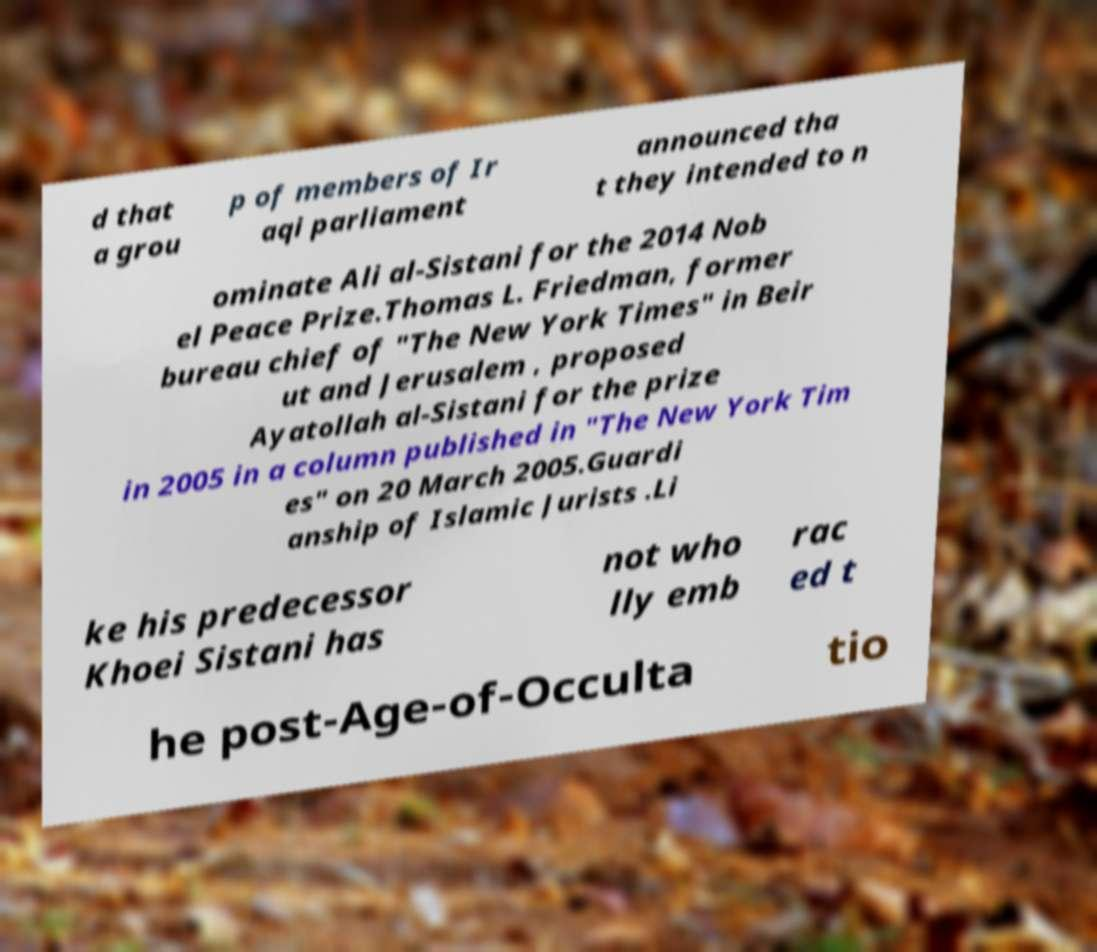I need the written content from this picture converted into text. Can you do that? d that a grou p of members of Ir aqi parliament announced tha t they intended to n ominate Ali al-Sistani for the 2014 Nob el Peace Prize.Thomas L. Friedman, former bureau chief of "The New York Times" in Beir ut and Jerusalem , proposed Ayatollah al-Sistani for the prize in 2005 in a column published in "The New York Tim es" on 20 March 2005.Guardi anship of Islamic Jurists .Li ke his predecessor Khoei Sistani has not who lly emb rac ed t he post-Age-of-Occulta tio 